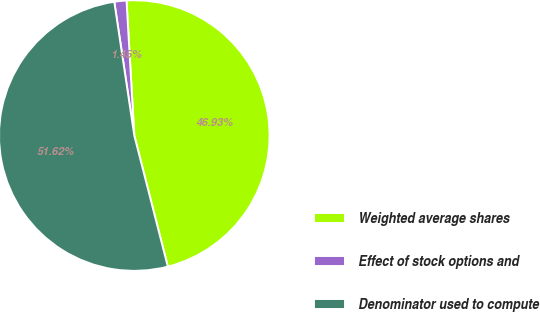Convert chart to OTSL. <chart><loc_0><loc_0><loc_500><loc_500><pie_chart><fcel>Weighted average shares<fcel>Effect of stock options and<fcel>Denominator used to compute<nl><fcel>46.93%<fcel>1.45%<fcel>51.62%<nl></chart> 